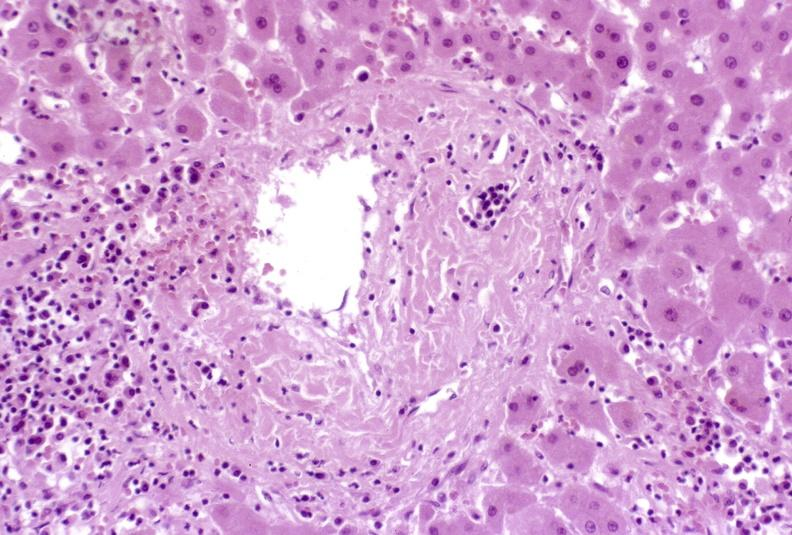s hepatobiliary present?
Answer the question using a single word or phrase. Yes 